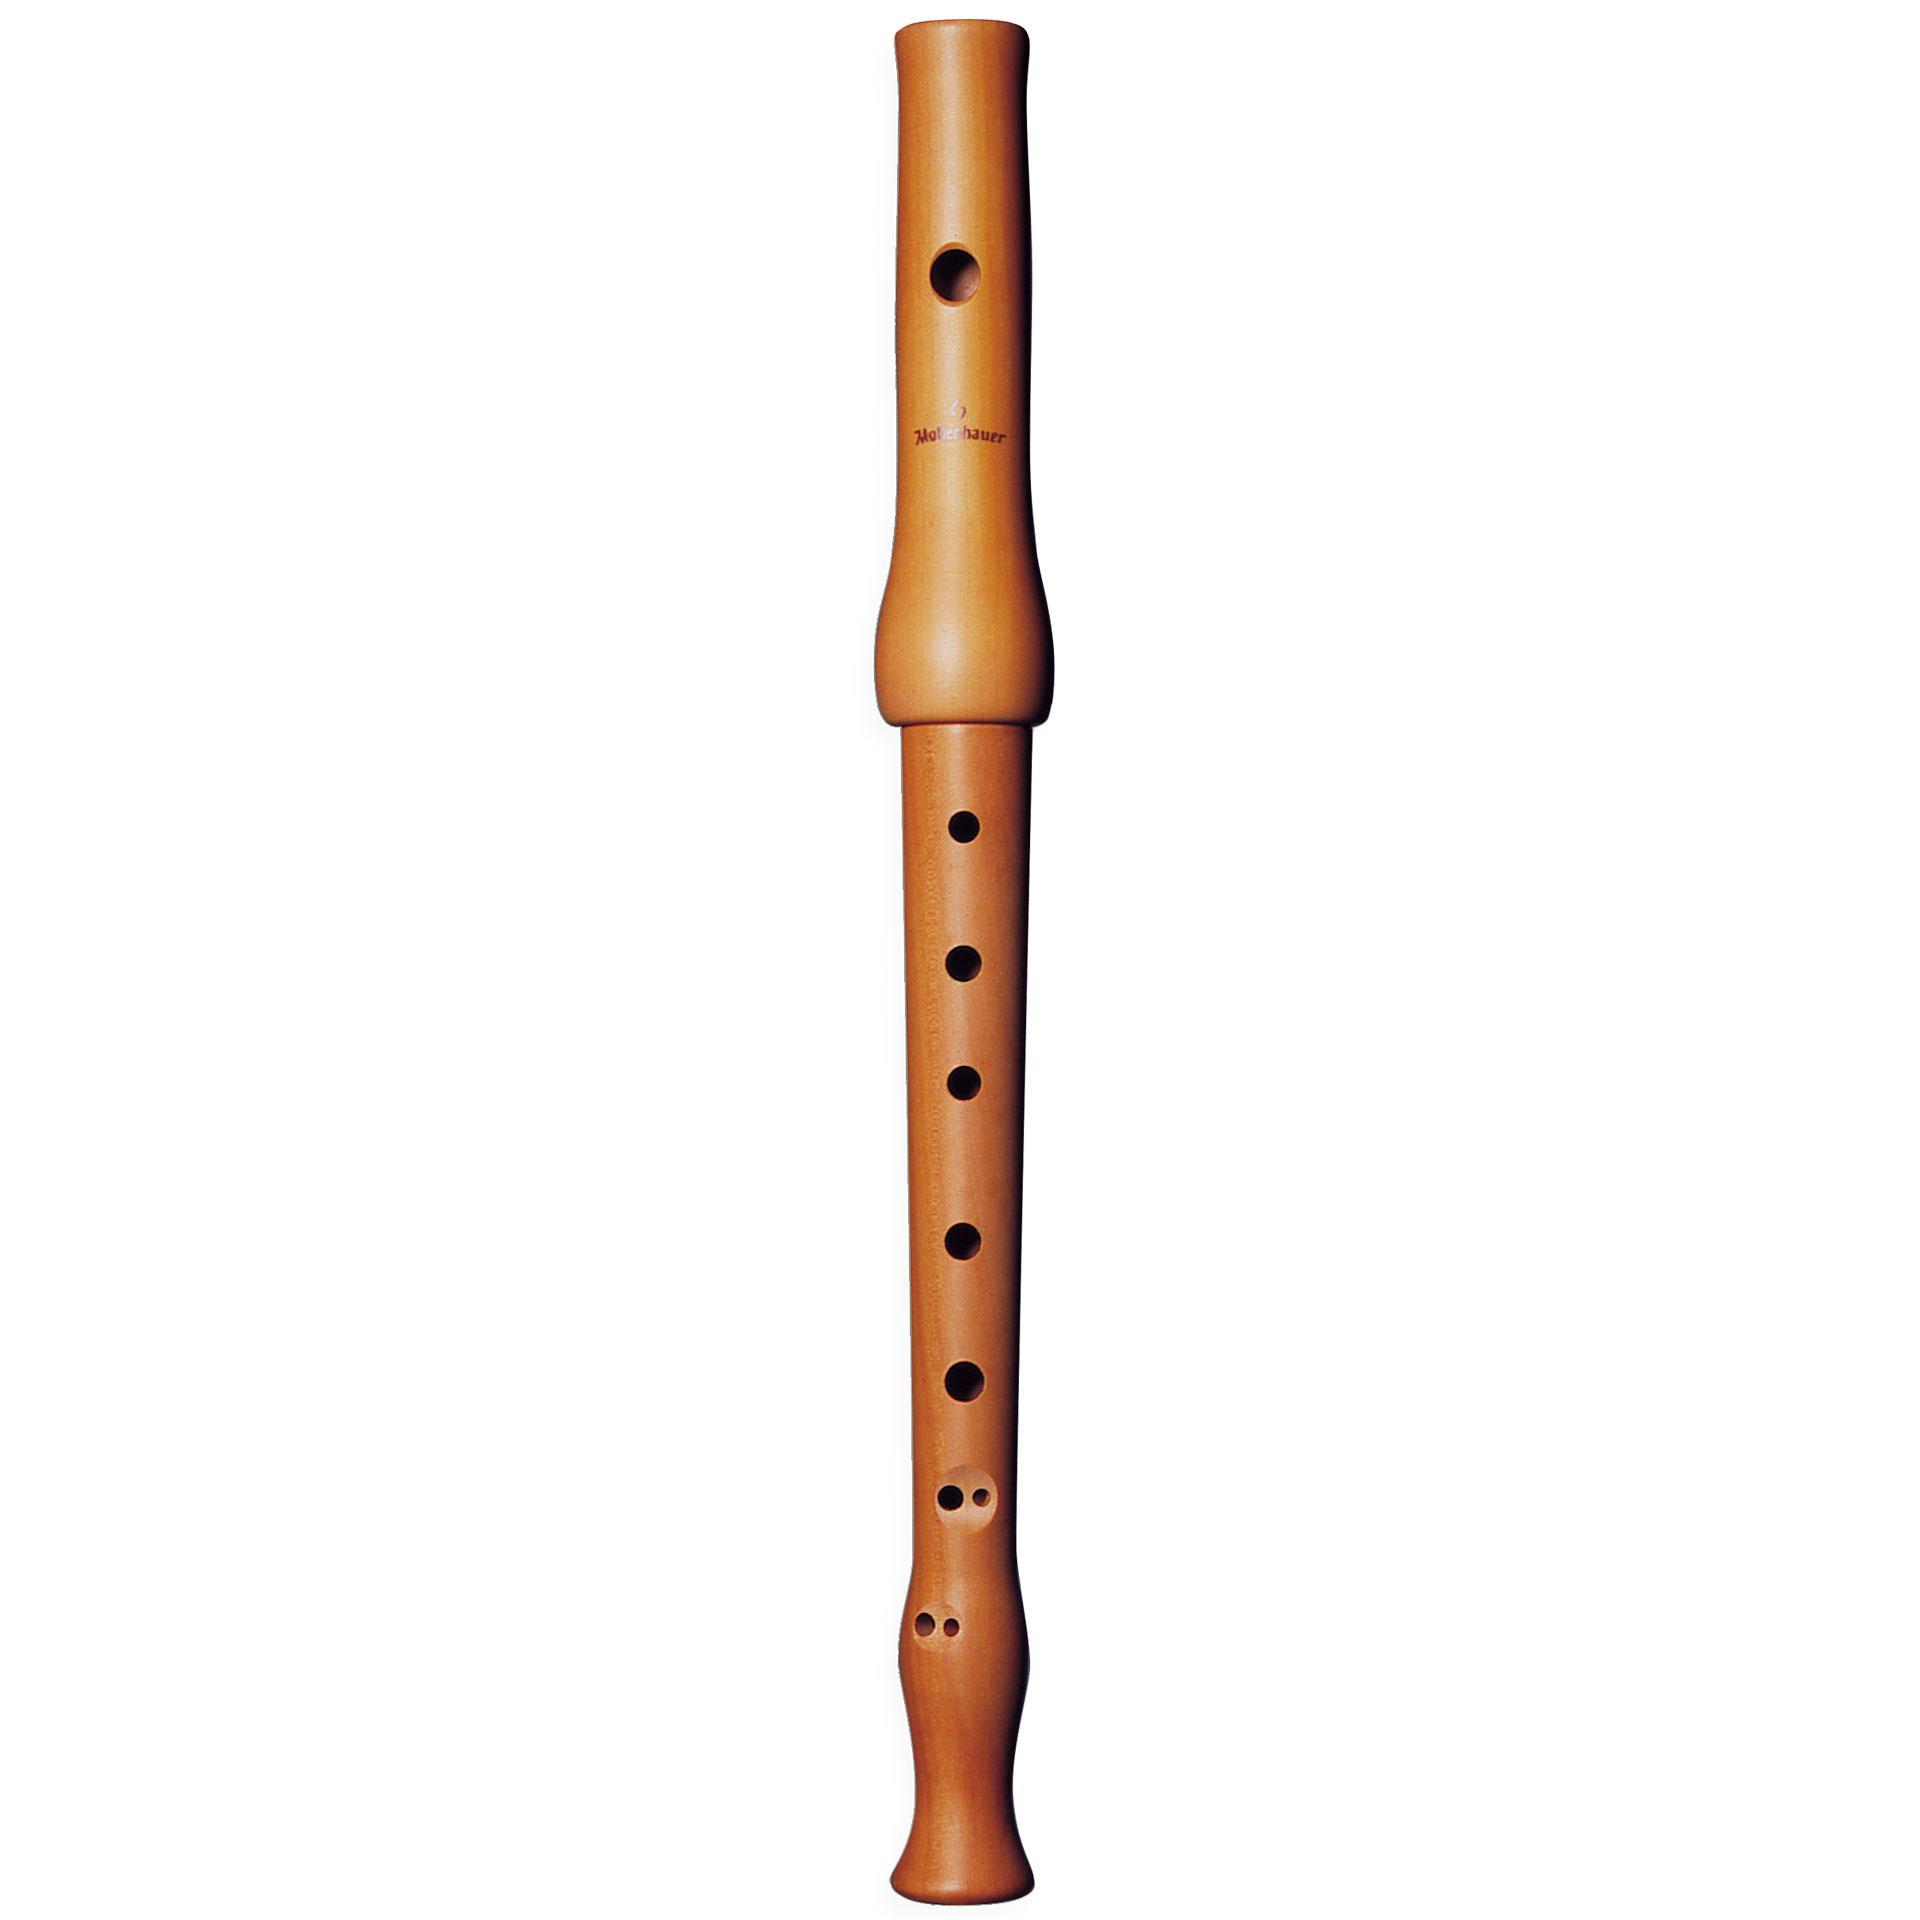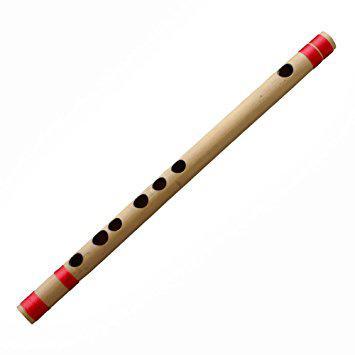The first image is the image on the left, the second image is the image on the right. For the images displayed, is the sentence "One image shows at least three flute items fanned out, with ends together at one end." factually correct? Answer yes or no. No. The first image is the image on the left, the second image is the image on the right. Evaluate the accuracy of this statement regarding the images: "There are at least four recorders.". Is it true? Answer yes or no. No. 